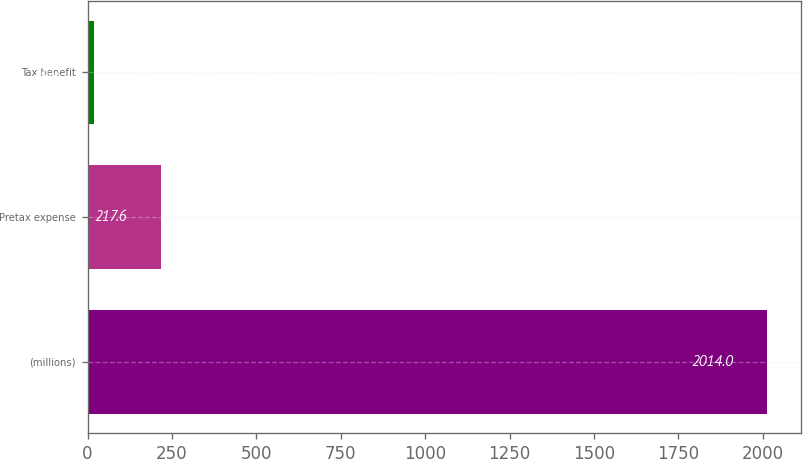Convert chart. <chart><loc_0><loc_0><loc_500><loc_500><bar_chart><fcel>(millions)<fcel>Pretax expense<fcel>Tax benefit<nl><fcel>2014<fcel>217.6<fcel>18<nl></chart> 